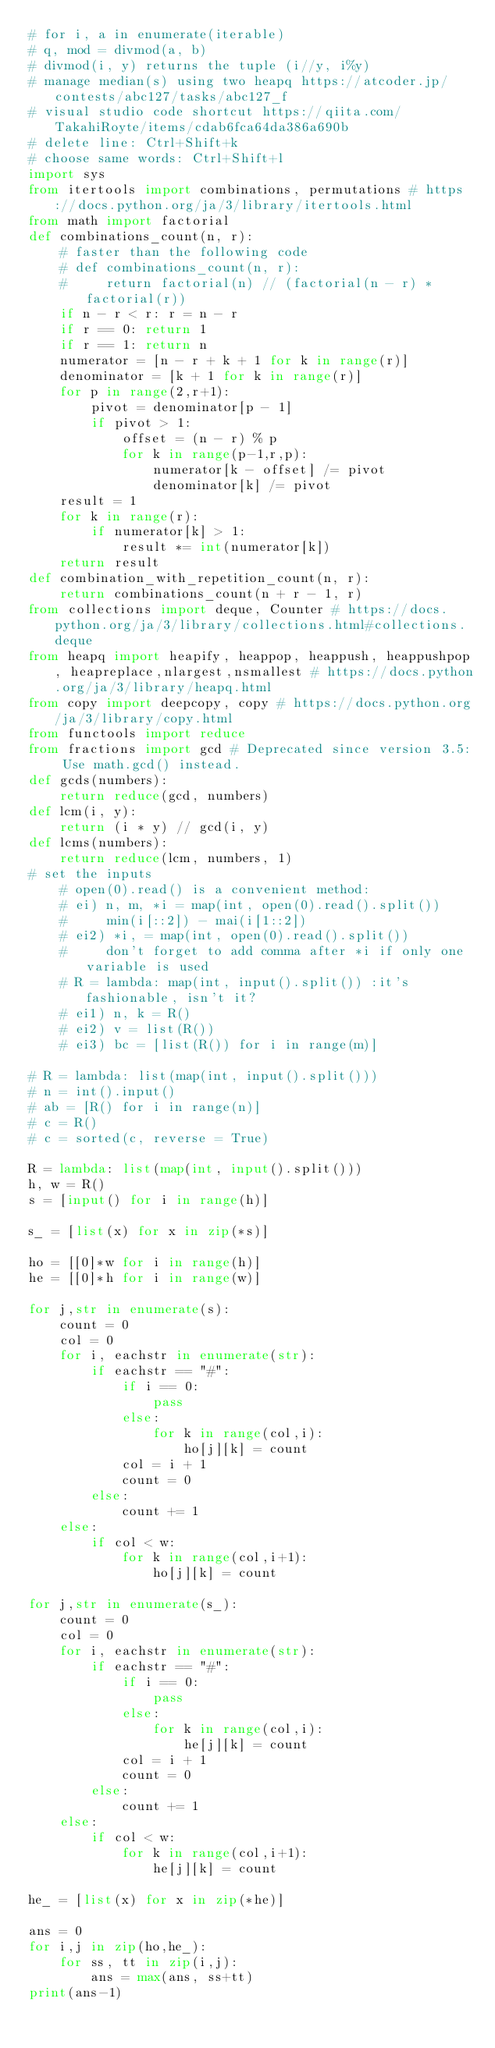Convert code to text. <code><loc_0><loc_0><loc_500><loc_500><_Python_># for i, a in enumerate(iterable)
# q, mod = divmod(a, b)
# divmod(i, y) returns the tuple (i//y, i%y)
# manage median(s) using two heapq https://atcoder.jp/contests/abc127/tasks/abc127_f
# visual studio code shortcut https://qiita.com/TakahiRoyte/items/cdab6fca64da386a690b
# delete line: Ctrl+Shift+k
# choose same words: Ctrl+Shift+l
import sys
from itertools import combinations, permutations # https://docs.python.org/ja/3/library/itertools.html
from math import factorial
def combinations_count(n, r):
    # faster than the following code
    # def combinations_count(n, r):
    #     return factorial(n) // (factorial(n - r) * factorial(r))
    if n - r < r: r = n - r
    if r == 0: return 1
    if r == 1: return n
    numerator = [n - r + k + 1 for k in range(r)]
    denominator = [k + 1 for k in range(r)]
    for p in range(2,r+1):
        pivot = denominator[p - 1]
        if pivot > 1:
            offset = (n - r) % p
            for k in range(p-1,r,p):
                numerator[k - offset] /= pivot
                denominator[k] /= pivot
    result = 1
    for k in range(r):
        if numerator[k] > 1:
            result *= int(numerator[k])
    return result
def combination_with_repetition_count(n, r):
    return combinations_count(n + r - 1, r)
from collections import deque, Counter # https://docs.python.org/ja/3/library/collections.html#collections.deque
from heapq import heapify, heappop, heappush, heappushpop, heapreplace,nlargest,nsmallest # https://docs.python.org/ja/3/library/heapq.html
from copy import deepcopy, copy # https://docs.python.org/ja/3/library/copy.html
from functools import reduce
from fractions import gcd # Deprecated since version 3.5: Use math.gcd() instead.
def gcds(numbers):
    return reduce(gcd, numbers)
def lcm(i, y):
    return (i * y) // gcd(i, y)
def lcms(numbers):
    return reduce(lcm, numbers, 1)
# set the inputs
    # open(0).read() is a convenient method:
    # ei) n, m, *i = map(int, open(0).read().split())
    #     min(i[::2]) - mai(i[1::2])
    # ei2) *i, = map(int, open(0).read().split())
    #     don't forget to add comma after *i if only one variable is used
    # R = lambda: map(int, input().split()) :it's fashionable, isn't it?
    # ei1) n, k = R()
    # ei2) v = list(R())
    # ei3) bc = [list(R()) for i in range(m)]

# R = lambda: list(map(int, input().split()))
# n = int().input()
# ab = [R() for i in range(n)]
# c = R()
# c = sorted(c, reverse = True)

R = lambda: list(map(int, input().split()))
h, w = R()
s = [input() for i in range(h)]

s_ = [list(x) for x in zip(*s)]

ho = [[0]*w for i in range(h)]
he = [[0]*h for i in range(w)]

for j,str in enumerate(s):
    count = 0
    col = 0
    for i, eachstr in enumerate(str):
        if eachstr == "#":
            if i == 0:
                pass
            else:
                for k in range(col,i):
                    ho[j][k] = count
            col = i + 1
            count = 0
        else:
            count += 1
    else:
        if col < w:
            for k in range(col,i+1):
                ho[j][k] = count

for j,str in enumerate(s_):
    count = 0
    col = 0
    for i, eachstr in enumerate(str):
        if eachstr == "#":
            if i == 0:
                pass
            else:
                for k in range(col,i):
                    he[j][k] = count
            col = i + 1
            count = 0
        else:
            count += 1
    else:
        if col < w:
            for k in range(col,i+1):
                he[j][k] = count

he_ = [list(x) for x in zip(*he)]

ans = 0
for i,j in zip(ho,he_):
    for ss, tt in zip(i,j):
        ans = max(ans, ss+tt)
print(ans-1)

</code> 